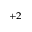<formula> <loc_0><loc_0><loc_500><loc_500>^ { + 2 }</formula> 